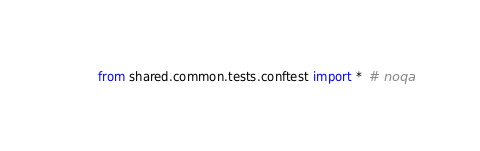Convert code to text. <code><loc_0><loc_0><loc_500><loc_500><_Python_>from shared.common.tests.conftest import *  # noqa
</code> 